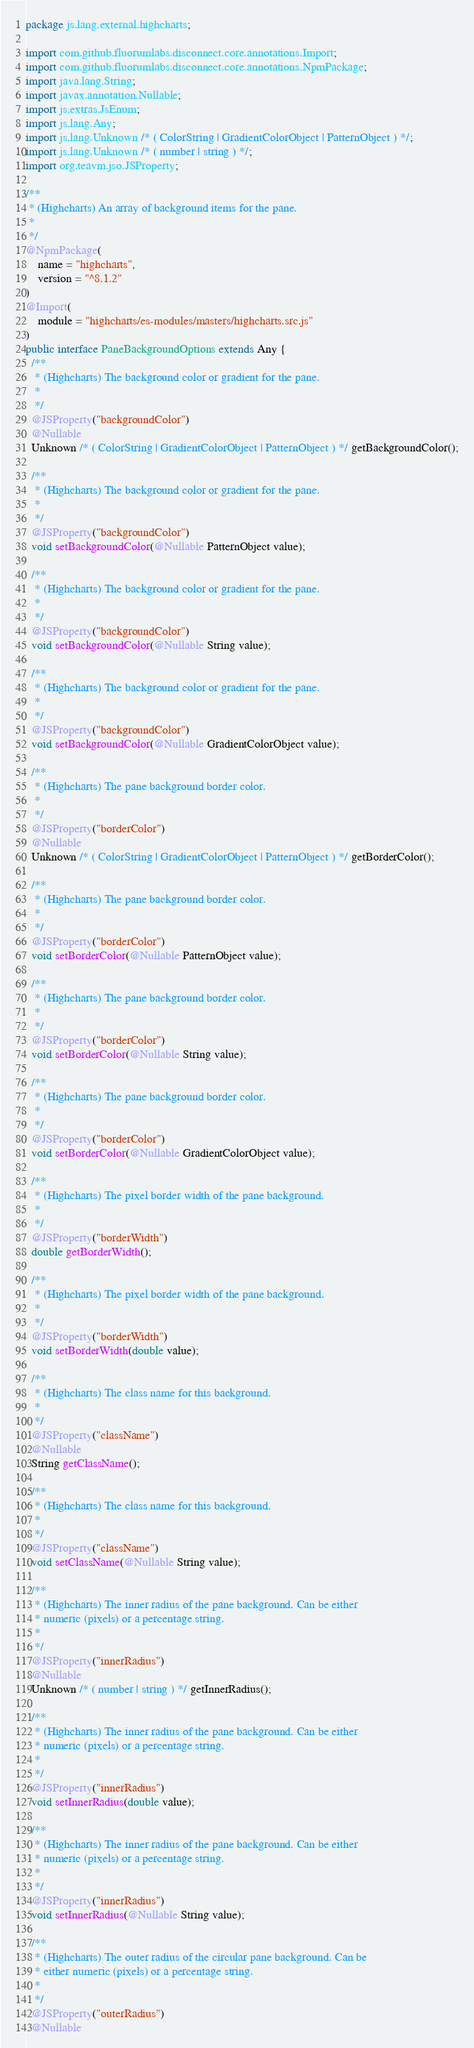Convert code to text. <code><loc_0><loc_0><loc_500><loc_500><_Java_>package js.lang.external.highcharts;

import com.github.fluorumlabs.disconnect.core.annotations.Import;
import com.github.fluorumlabs.disconnect.core.annotations.NpmPackage;
import java.lang.String;
import javax.annotation.Nullable;
import js.extras.JsEnum;
import js.lang.Any;
import js.lang.Unknown /* ( ColorString | GradientColorObject | PatternObject ) */;
import js.lang.Unknown /* ( number | string ) */;
import org.teavm.jso.JSProperty;

/**
 * (Highcharts) An array of background items for the pane.
 *
 */
@NpmPackage(
    name = "highcharts",
    version = "^8.1.2"
)
@Import(
    module = "highcharts/es-modules/masters/highcharts.src.js"
)
public interface PaneBackgroundOptions extends Any {
  /**
   * (Highcharts) The background color or gradient for the pane.
   *
   */
  @JSProperty("backgroundColor")
  @Nullable
  Unknown /* ( ColorString | GradientColorObject | PatternObject ) */ getBackgroundColor();

  /**
   * (Highcharts) The background color or gradient for the pane.
   *
   */
  @JSProperty("backgroundColor")
  void setBackgroundColor(@Nullable PatternObject value);

  /**
   * (Highcharts) The background color or gradient for the pane.
   *
   */
  @JSProperty("backgroundColor")
  void setBackgroundColor(@Nullable String value);

  /**
   * (Highcharts) The background color or gradient for the pane.
   *
   */
  @JSProperty("backgroundColor")
  void setBackgroundColor(@Nullable GradientColorObject value);

  /**
   * (Highcharts) The pane background border color.
   *
   */
  @JSProperty("borderColor")
  @Nullable
  Unknown /* ( ColorString | GradientColorObject | PatternObject ) */ getBorderColor();

  /**
   * (Highcharts) The pane background border color.
   *
   */
  @JSProperty("borderColor")
  void setBorderColor(@Nullable PatternObject value);

  /**
   * (Highcharts) The pane background border color.
   *
   */
  @JSProperty("borderColor")
  void setBorderColor(@Nullable String value);

  /**
   * (Highcharts) The pane background border color.
   *
   */
  @JSProperty("borderColor")
  void setBorderColor(@Nullable GradientColorObject value);

  /**
   * (Highcharts) The pixel border width of the pane background.
   *
   */
  @JSProperty("borderWidth")
  double getBorderWidth();

  /**
   * (Highcharts) The pixel border width of the pane background.
   *
   */
  @JSProperty("borderWidth")
  void setBorderWidth(double value);

  /**
   * (Highcharts) The class name for this background.
   *
   */
  @JSProperty("className")
  @Nullable
  String getClassName();

  /**
   * (Highcharts) The class name for this background.
   *
   */
  @JSProperty("className")
  void setClassName(@Nullable String value);

  /**
   * (Highcharts) The inner radius of the pane background. Can be either
   * numeric (pixels) or a percentage string.
   *
   */
  @JSProperty("innerRadius")
  @Nullable
  Unknown /* ( number | string ) */ getInnerRadius();

  /**
   * (Highcharts) The inner radius of the pane background. Can be either
   * numeric (pixels) or a percentage string.
   *
   */
  @JSProperty("innerRadius")
  void setInnerRadius(double value);

  /**
   * (Highcharts) The inner radius of the pane background. Can be either
   * numeric (pixels) or a percentage string.
   *
   */
  @JSProperty("innerRadius")
  void setInnerRadius(@Nullable String value);

  /**
   * (Highcharts) The outer radius of the circular pane background. Can be
   * either numeric (pixels) or a percentage string.
   *
   */
  @JSProperty("outerRadius")
  @Nullable</code> 